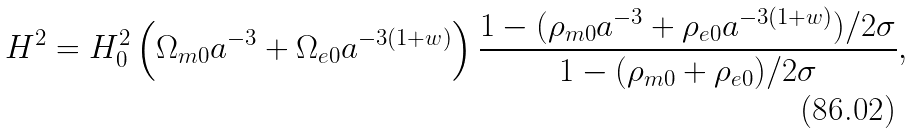<formula> <loc_0><loc_0><loc_500><loc_500>H ^ { 2 } = H _ { 0 } ^ { 2 } \left ( \Omega _ { m 0 } a ^ { - 3 } + \Omega _ { e 0 } a ^ { - 3 ( 1 + w ) } \right ) \frac { 1 - ( \rho _ { m 0 } a ^ { - 3 } + \rho _ { e 0 } a ^ { - 3 ( 1 + w ) } ) / 2 \sigma } { 1 - ( \rho _ { m 0 } + \rho _ { e 0 } ) / 2 \sigma } ,</formula> 